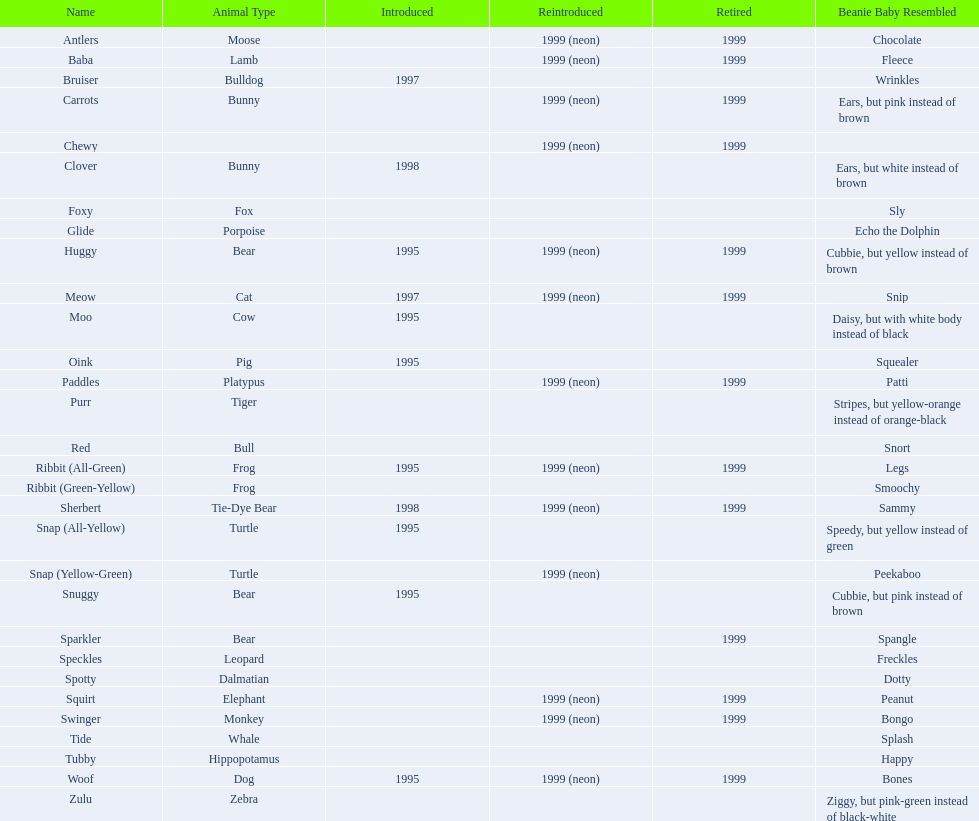Which of the listed pillow pals lack information in at least 3 categories? Chewy, Foxy, Glide, Purr, Red, Ribbit (Green-Yellow), Speckles, Spotty, Tide, Tubby, Zulu. Of those, which one lacks information in the animal type category? Chewy. 